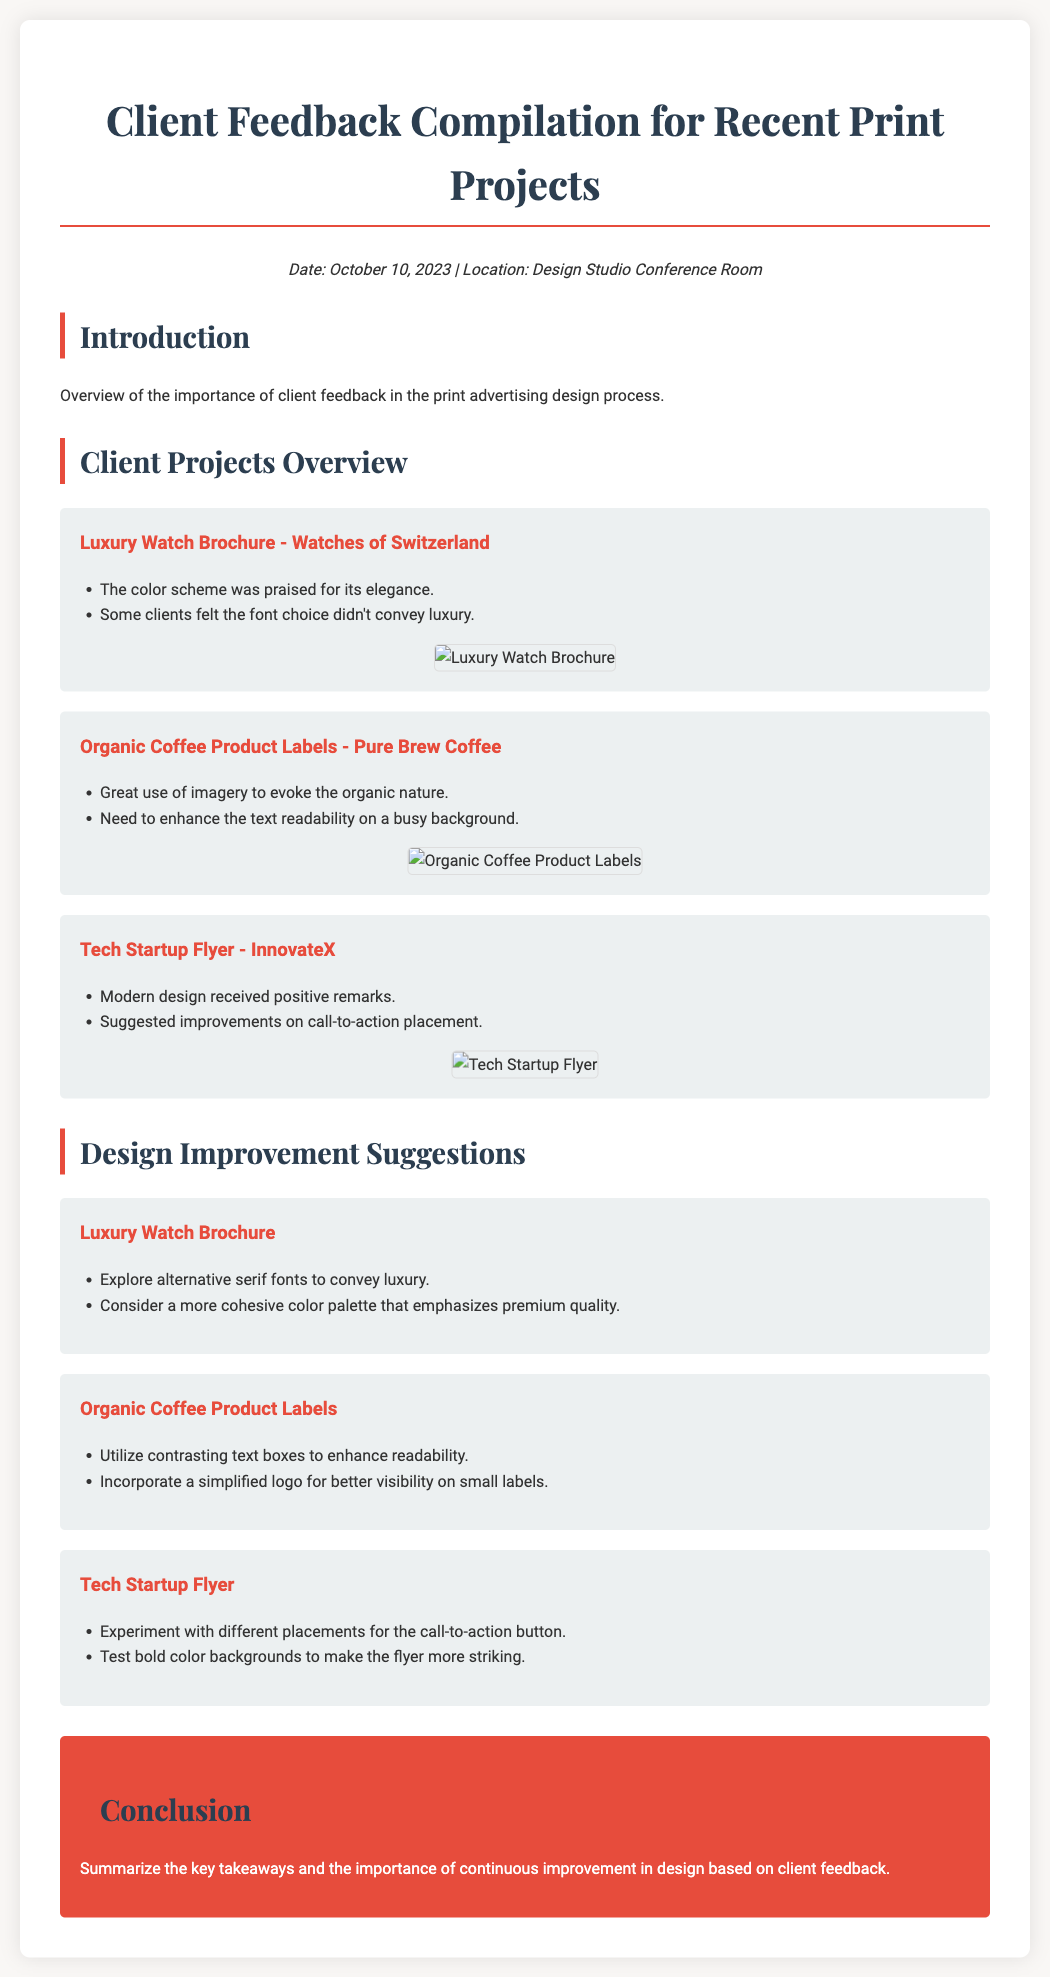what is the date of the feedback compilation? The date is mentioned at the top of the document, indicating when the feedback compilation was prepared.
Answer: October 10, 2023 which client project received feedback on color scheme elegance? The project concerned is listed under client projects, highlighting the feedback received regarding its color scheme.
Answer: Luxury Watch Brochure what is one suggestion for improving the Organic Coffee Product Labels? The suggestions for improvement are listed specifically under each project, indicating actionable feedback.
Answer: Utilize contrasting text boxes to enhance readability how many projects are discussed in this document? The number of projects can be counted from the sections dedicated to client projects mentioned in the document.
Answer: Three which project had a suggestion related to call-to-action placement? This detail can be found in the feedback section specific to the project, highlighting areas for improvement.
Answer: Tech Startup Flyer what was praised about the Tech Startup Flyer? The specific feedback for each project highlights positive aspects and received remarks about the designs.
Answer: Modern design received positive remarks what is the purpose of client feedback in print advertising design? The introduction section outlines the significance of feedback in enhancing design quality and alignment with client expectations.
Answer: Importance of client feedback which color is associated with the document's headings? The style elements specify colors used in the design to maintain consistency across headings and sections.
Answer: #e74c3c what type of document is this? The overall structure and intent of the document can be derived from its content related to projects and feedback.
Answer: Client Feedback Compilation 